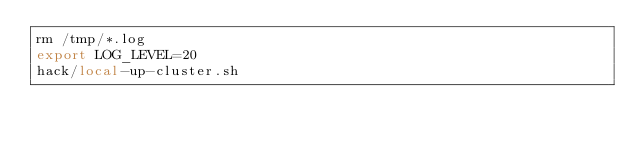Convert code to text. <code><loc_0><loc_0><loc_500><loc_500><_Bash_>rm /tmp/*.log 
export LOG_LEVEL=20
hack/local-up-cluster.sh
</code> 